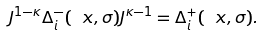Convert formula to latex. <formula><loc_0><loc_0><loc_500><loc_500>J ^ { 1 - \kappa } \Delta _ { i } ^ { - } ( \ x , \sigma ) J ^ { \kappa - 1 } = \Delta _ { i } ^ { + } ( \ x , \sigma ) .</formula> 